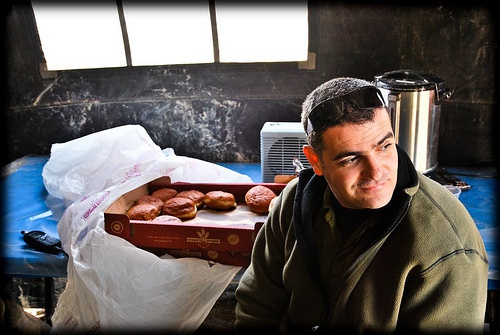Describe the objects in this image and their specific colors. I can see people in black, tan, gray, and maroon tones, dining table in black, blue, and navy tones, cell phone in black, navy, gray, and blue tones, donut in black, maroon, brown, and lightpink tones, and donut in black, maroon, lightpink, pink, and brown tones in this image. 